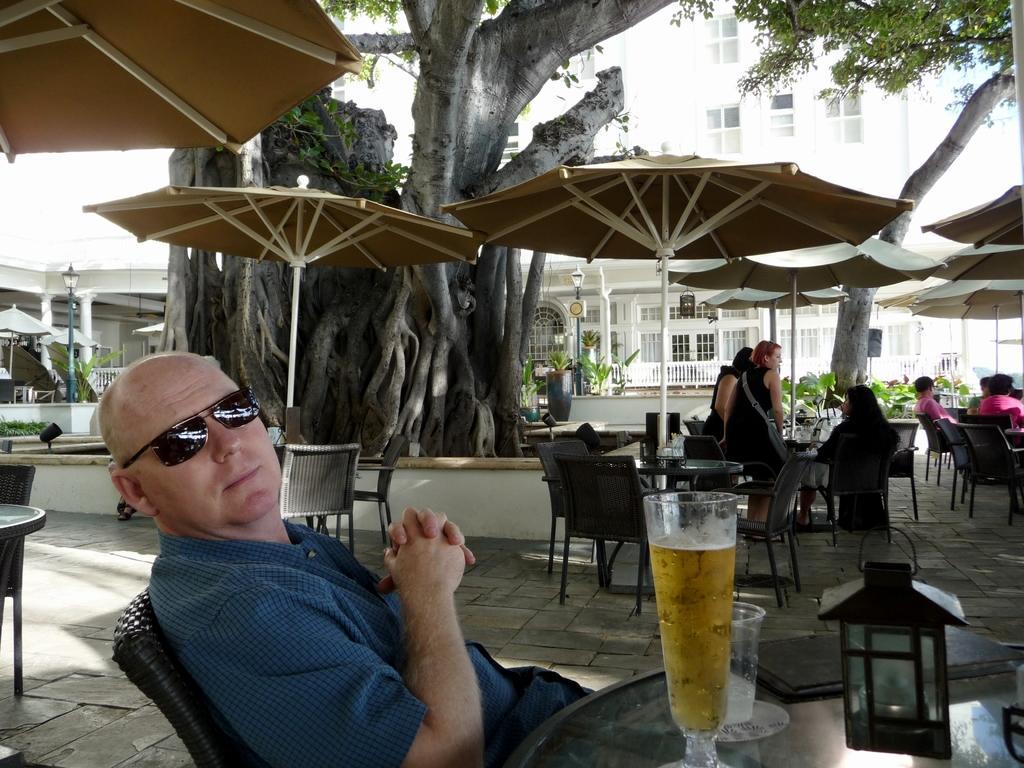In one or two sentences, can you explain what this image depicts? This person is sitting on a chair and wore goggles. In-front of this person there is a table, on a table there is a file, glass and a liquid with glass. This is a tree. This is a building with window and fence. This are umbrellas with pole. Far there are chairs and tables. This 2 persons are standing and this persons are sitting on a chair. Far there are plants. This is a lantern light with pole. 